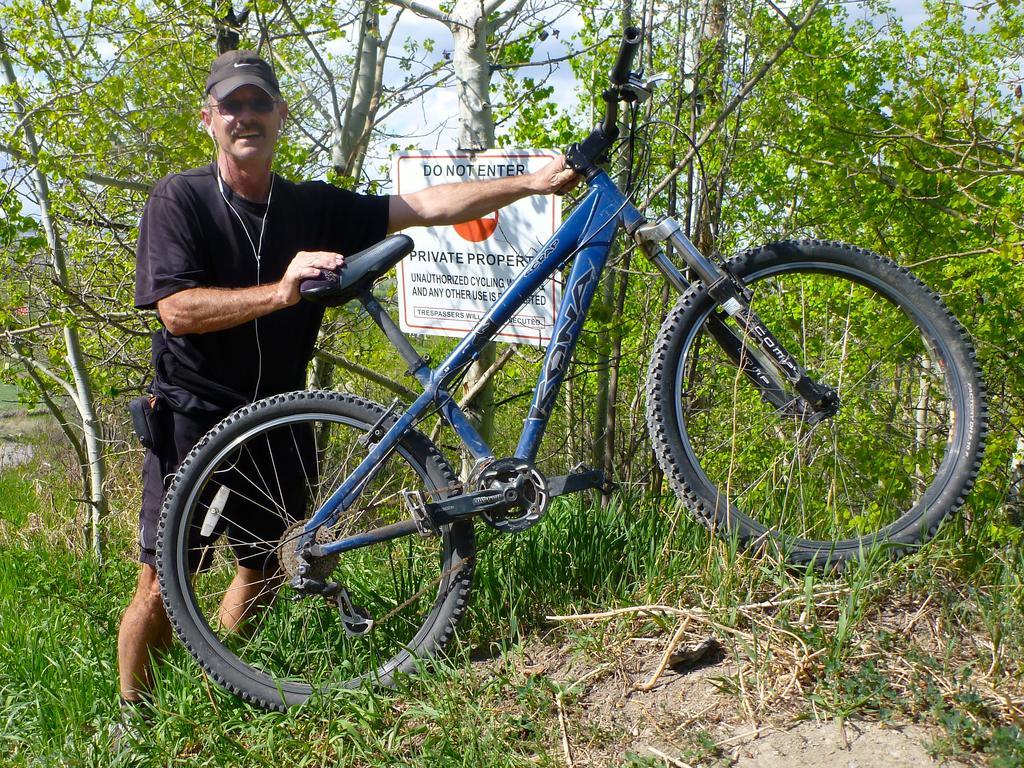Describe this image in one or two sentences. In this image we can see a man is holding a bicycle with his hands which is on the ground and there is a cap on his head. In the background there are trees, a board on the tree, plants and grass on the ground and clouds in the sky. 